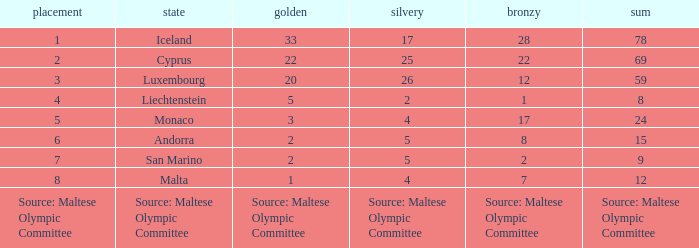What rank is the nation that has a bronze of source: Maltese Olympic Committee? Source: Maltese Olympic Committee. 